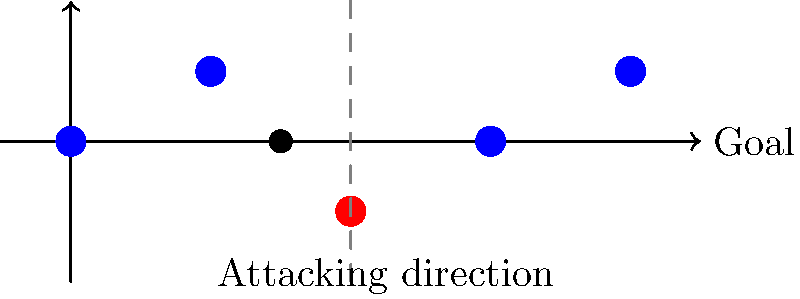In this Kaya-Iloilo match scenario, the red player is an attacker, and the blue players are defenders. The black dot represents the ball. At what x-coordinate should the offside line be drawn? To determine the offside line position, we need to follow these steps:

1. Identify the attacking direction (right, in this case).
2. Locate the second-last defender (excluding the goalkeeper).
3. Draw an imaginary line parallel to the goal line through this defender's position.

In this scenario:
1. The attacking direction is towards the right (as labeled).
2. The defenders (blue dots) are positioned at x-coordinates 0, 2, 6, and 8.
3. The second-last defender is at x-coordinate 6.

Therefore, the offside line should be drawn at x-coordinate 6, which is represented by the gray dashed line in the diagram.

Note: The offside line is always determined by the position of the second-last defender or the ball, whichever is closer to the defending team's goal line. In this case, the ball (at x = 3) is behind the second-last defender (at x = 6), so the defender's position determines the offside line.
Answer: x = 6 